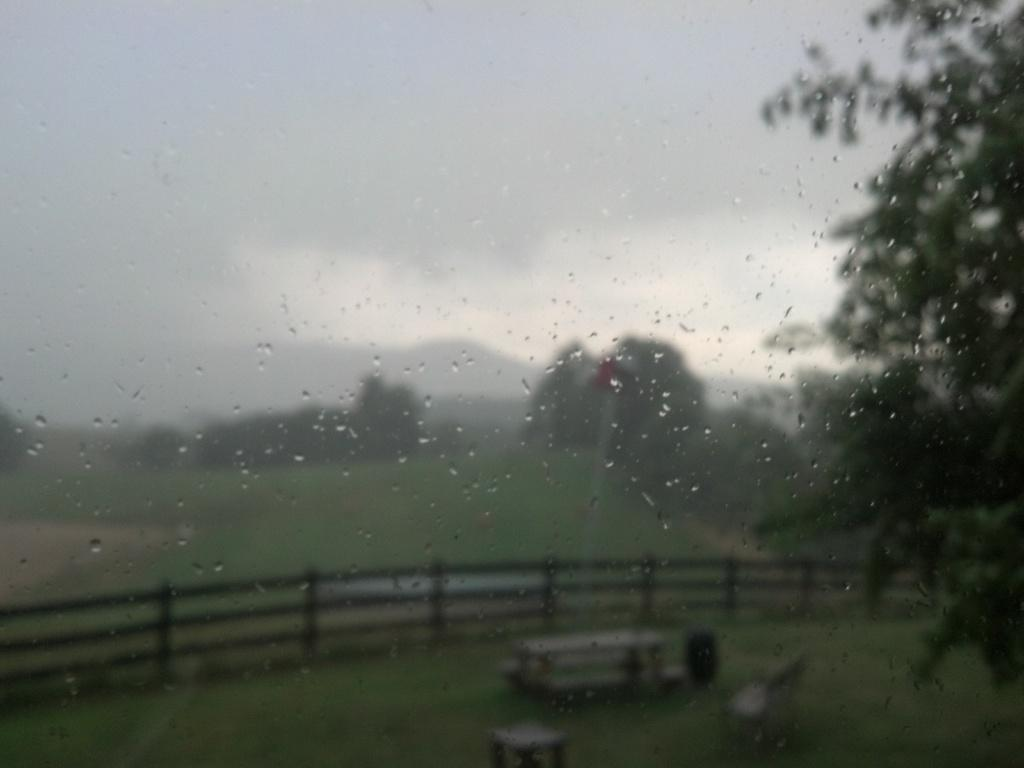What can be seen on the glass panes in the image? There are water droplets on the glass panes. What type of vegetation is visible in the background of the image? There are trees and grass in the background of the image. What type of structure is present in the background of the image? There is a bench in the background of the image. What type of barrier is present in the background of the image? There is a wooden fence in the background of the image. What type of potato is being used as a business card holder on the bench in the image? There is no potato or business card holder present in the image. Can you see any bones in the image? There are no bones visible in the image. 